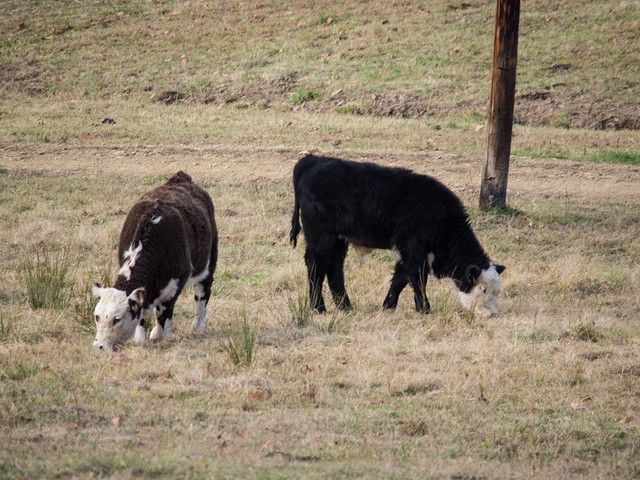Describe the objects in this image and their specific colors. I can see cow in gray, black, and darkgray tones and cow in gray, black, and darkgray tones in this image. 